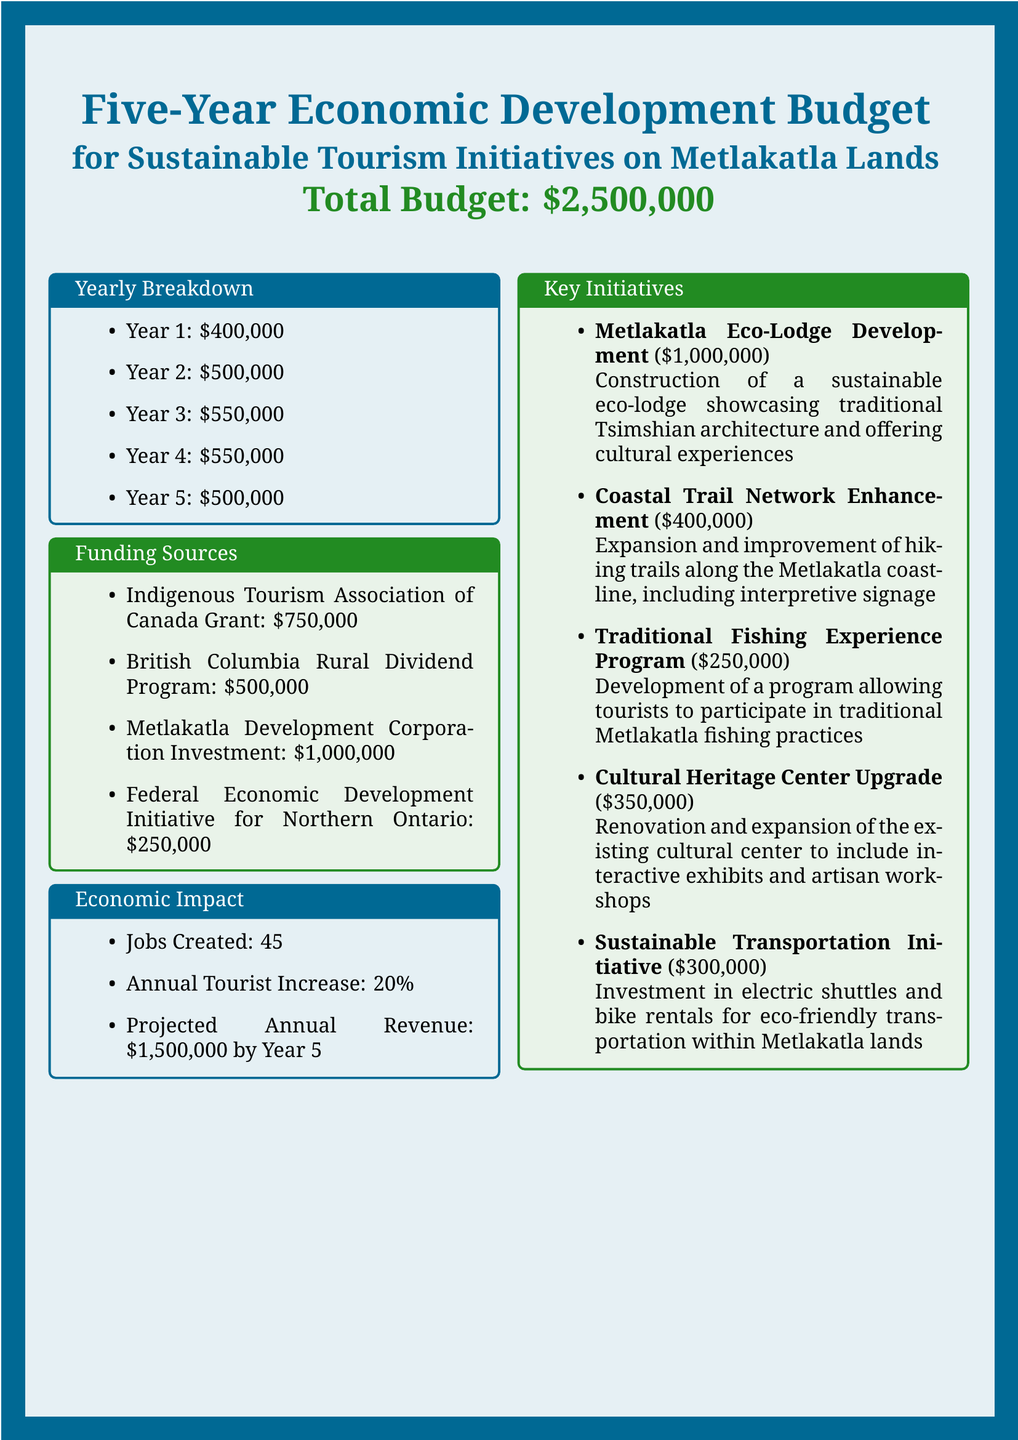what is the total budget? The total budget for the five-year economic development initiatives is stated clearly in the document.
Answer: $2,500,000 how much funding is allocated in Year 3? The yearly breakdown outlines specific funding amounts for each year, including Year 3.
Answer: $550,000 what is the projected annual revenue by Year 5? The economic impact section details projected financial outcomes, specifically stating the expected revenue by Year 5.
Answer: $1,500,000 how many jobs will be created? The document states a specific number of jobs that are expected to be created through these initiatives.
Answer: 45 what is the name of the eco-lodge development project? The key initiatives section identifies prominent projects, including the eco-lodge development and its purpose.
Answer: Metlakatla Eco-Lodge Development how much funding is sourced from the Indigenous Tourism Association of Canada? The funding sources section lists amounts from various sources, including this specific grant.
Answer: $750,000 what is one expected benefit of the Coastal Trail Network Enhancement? The key initiatives section describes the purpose of the Coastal Trail Network Enhancement, focused on improvement and expansion.
Answer: Hiking trails what is the budget for the Sustainable Transportation Initiative? The key initiatives section specifies the financial allocation for each project, including the Sustainable Transportation Initiative.
Answer: $300,000 in which year is the maximum budget allocation planned? By analyzing the yearly breakdown, the highest amount allocated should be identified.
Answer: Year 2 